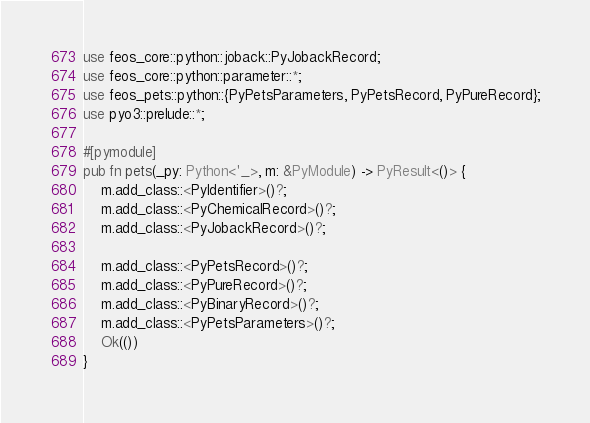<code> <loc_0><loc_0><loc_500><loc_500><_Rust_>use feos_core::python::joback::PyJobackRecord;
use feos_core::python::parameter::*;
use feos_pets::python::{PyPetsParameters, PyPetsRecord, PyPureRecord};
use pyo3::prelude::*;

#[pymodule]
pub fn pets(_py: Python<'_>, m: &PyModule) -> PyResult<()> {
    m.add_class::<PyIdentifier>()?;
    m.add_class::<PyChemicalRecord>()?;
    m.add_class::<PyJobackRecord>()?;

    m.add_class::<PyPetsRecord>()?;
    m.add_class::<PyPureRecord>()?;
    m.add_class::<PyBinaryRecord>()?;
    m.add_class::<PyPetsParameters>()?;
    Ok(())
}
</code> 